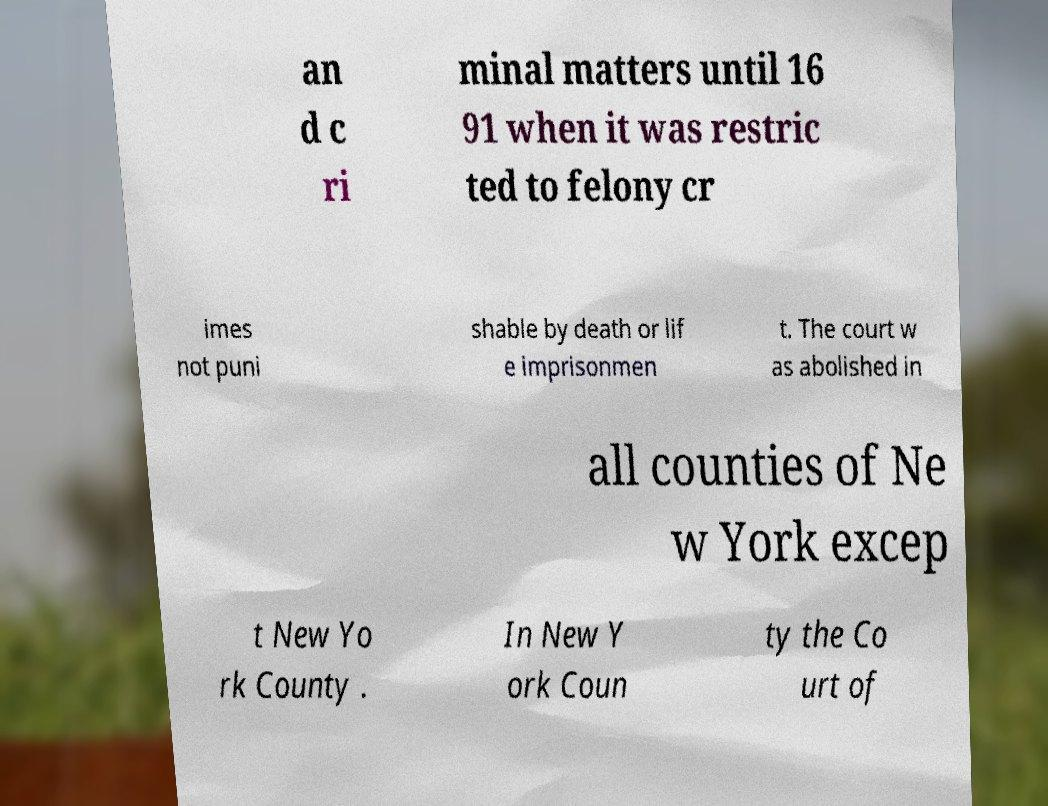Could you extract and type out the text from this image? an d c ri minal matters until 16 91 when it was restric ted to felony cr imes not puni shable by death or lif e imprisonmen t. The court w as abolished in all counties of Ne w York excep t New Yo rk County . In New Y ork Coun ty the Co urt of 